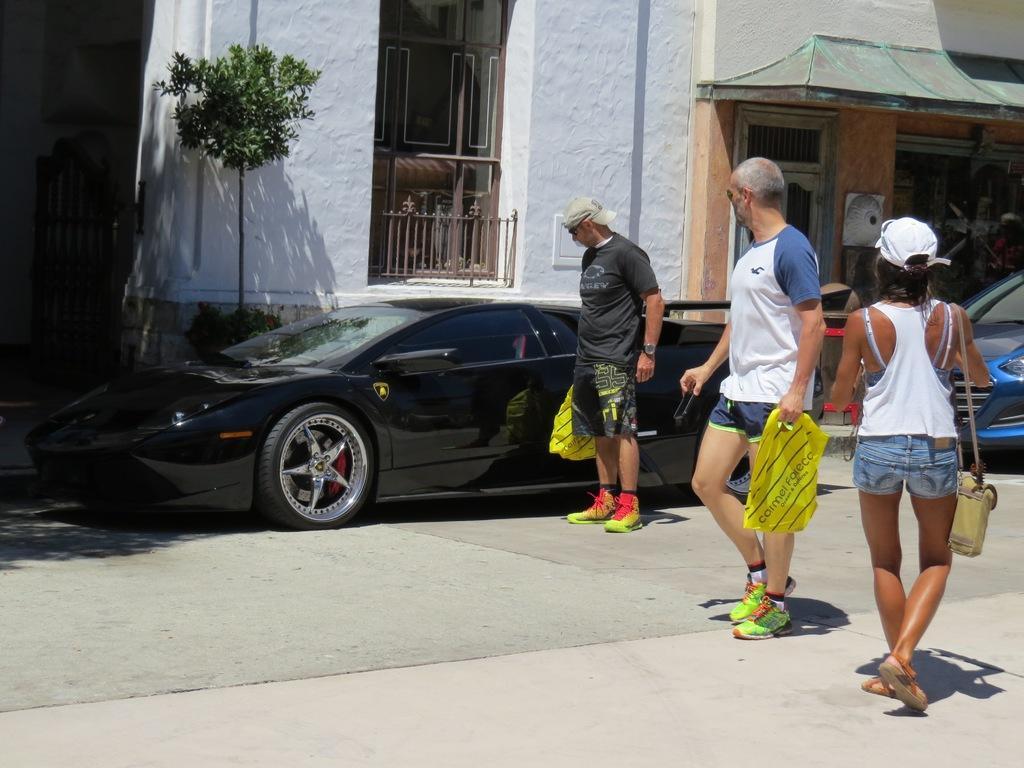Describe this image in one or two sentences. In this picture there are three persons standing and carrying an object are looking at a black color car in front of them and there is another car in the right corner and there are buildings in the background. 